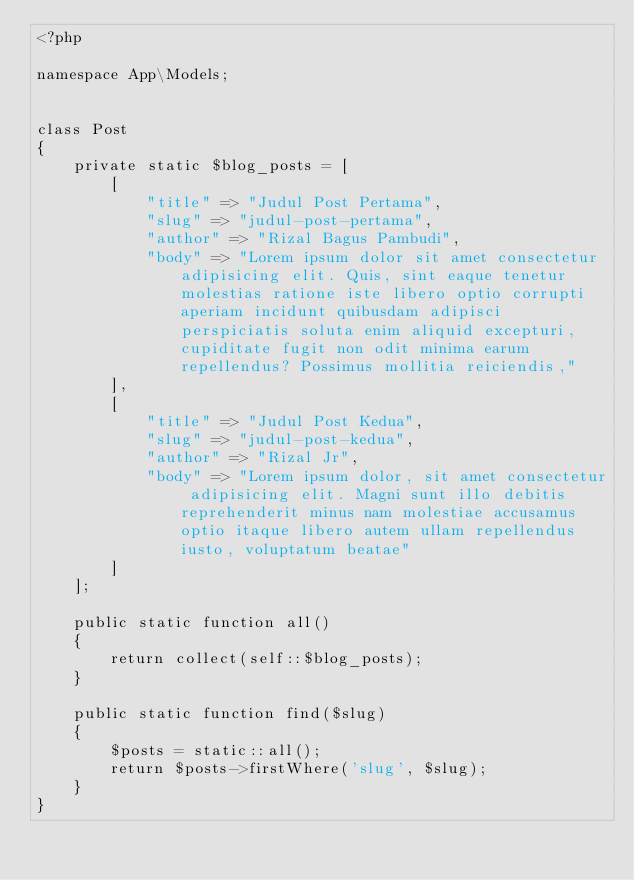<code> <loc_0><loc_0><loc_500><loc_500><_PHP_><?php

namespace App\Models;


class Post
{
    private static $blog_posts = [
        [
            "title" => "Judul Post Pertama",
            "slug" => "judul-post-pertama",
            "author" => "Rizal Bagus Pambudi",
            "body" => "Lorem ipsum dolor sit amet consectetur adipisicing elit. Quis, sint eaque tenetur molestias ratione iste libero optio corrupti aperiam incidunt quibusdam adipisci perspiciatis soluta enim aliquid excepturi, cupiditate fugit non odit minima earum repellendus? Possimus mollitia reiciendis,"
        ],
        [
            "title" => "Judul Post Kedua",
            "slug" => "judul-post-kedua",
            "author" => "Rizal Jr",
            "body" => "Lorem ipsum dolor, sit amet consectetur adipisicing elit. Magni sunt illo debitis reprehenderit minus nam molestiae accusamus optio itaque libero autem ullam repellendus iusto, voluptatum beatae"
        ]
    ];

    public static function all()
    {
        return collect(self::$blog_posts);
    }

    public static function find($slug)
    {
        $posts = static::all();
        return $posts->firstWhere('slug', $slug);
    }
}
</code> 